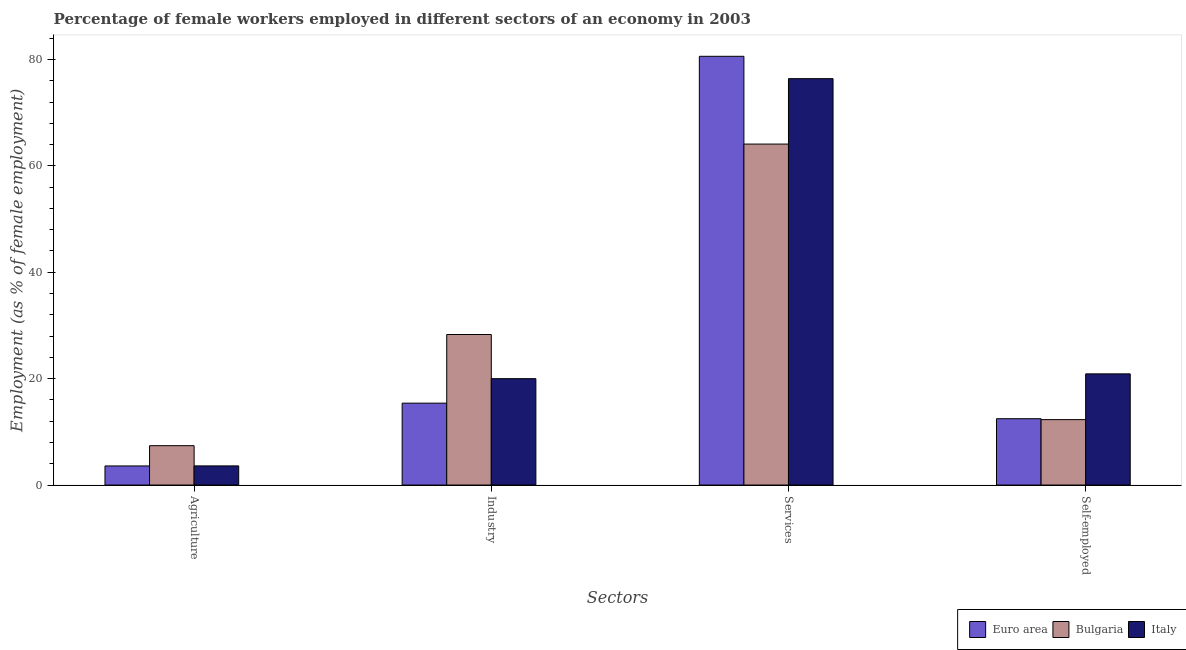How many different coloured bars are there?
Give a very brief answer. 3. How many groups of bars are there?
Your answer should be compact. 4. Are the number of bars per tick equal to the number of legend labels?
Provide a succinct answer. Yes. Are the number of bars on each tick of the X-axis equal?
Offer a terse response. Yes. How many bars are there on the 4th tick from the right?
Ensure brevity in your answer.  3. What is the label of the 2nd group of bars from the left?
Give a very brief answer. Industry. What is the percentage of female workers in services in Italy?
Your response must be concise. 76.4. Across all countries, what is the maximum percentage of self employed female workers?
Ensure brevity in your answer.  20.9. Across all countries, what is the minimum percentage of female workers in services?
Make the answer very short. 64.1. In which country was the percentage of female workers in agriculture maximum?
Provide a succinct answer. Bulgaria. What is the total percentage of female workers in services in the graph?
Keep it short and to the point. 221.1. What is the difference between the percentage of female workers in agriculture in Bulgaria and that in Euro area?
Ensure brevity in your answer.  3.81. What is the difference between the percentage of female workers in services in Italy and the percentage of female workers in industry in Bulgaria?
Make the answer very short. 48.1. What is the average percentage of self employed female workers per country?
Offer a very short reply. 15.22. What is the difference between the percentage of female workers in industry and percentage of female workers in services in Italy?
Keep it short and to the point. -56.4. In how many countries, is the percentage of female workers in services greater than 16 %?
Ensure brevity in your answer.  3. What is the ratio of the percentage of self employed female workers in Bulgaria to that in Euro area?
Give a very brief answer. 0.99. Is the percentage of female workers in services in Euro area less than that in Italy?
Offer a very short reply. No. Is the difference between the percentage of female workers in agriculture in Italy and Bulgaria greater than the difference between the percentage of female workers in industry in Italy and Bulgaria?
Your answer should be compact. Yes. What is the difference between the highest and the second highest percentage of female workers in industry?
Your response must be concise. 8.3. What is the difference between the highest and the lowest percentage of female workers in agriculture?
Keep it short and to the point. 3.81. Is the sum of the percentage of female workers in agriculture in Bulgaria and Italy greater than the maximum percentage of female workers in industry across all countries?
Keep it short and to the point. No. Is it the case that in every country, the sum of the percentage of female workers in services and percentage of female workers in industry is greater than the sum of percentage of self employed female workers and percentage of female workers in agriculture?
Make the answer very short. Yes. What does the 2nd bar from the right in Agriculture represents?
Give a very brief answer. Bulgaria. Is it the case that in every country, the sum of the percentage of female workers in agriculture and percentage of female workers in industry is greater than the percentage of female workers in services?
Provide a short and direct response. No. Are all the bars in the graph horizontal?
Offer a terse response. No. Are the values on the major ticks of Y-axis written in scientific E-notation?
Make the answer very short. No. Does the graph contain any zero values?
Provide a short and direct response. No. Does the graph contain grids?
Your answer should be compact. No. How are the legend labels stacked?
Your response must be concise. Horizontal. What is the title of the graph?
Offer a terse response. Percentage of female workers employed in different sectors of an economy in 2003. Does "Bolivia" appear as one of the legend labels in the graph?
Make the answer very short. No. What is the label or title of the X-axis?
Your answer should be very brief. Sectors. What is the label or title of the Y-axis?
Your answer should be very brief. Employment (as % of female employment). What is the Employment (as % of female employment) in Euro area in Agriculture?
Your answer should be compact. 3.59. What is the Employment (as % of female employment) of Bulgaria in Agriculture?
Keep it short and to the point. 7.4. What is the Employment (as % of female employment) of Italy in Agriculture?
Offer a very short reply. 3.6. What is the Employment (as % of female employment) of Euro area in Industry?
Your response must be concise. 15.4. What is the Employment (as % of female employment) in Bulgaria in Industry?
Make the answer very short. 28.3. What is the Employment (as % of female employment) in Italy in Industry?
Provide a short and direct response. 20. What is the Employment (as % of female employment) of Euro area in Services?
Provide a short and direct response. 80.6. What is the Employment (as % of female employment) in Bulgaria in Services?
Provide a succinct answer. 64.1. What is the Employment (as % of female employment) of Italy in Services?
Offer a terse response. 76.4. What is the Employment (as % of female employment) in Euro area in Self-employed?
Provide a short and direct response. 12.47. What is the Employment (as % of female employment) in Bulgaria in Self-employed?
Your response must be concise. 12.3. What is the Employment (as % of female employment) of Italy in Self-employed?
Offer a terse response. 20.9. Across all Sectors, what is the maximum Employment (as % of female employment) of Euro area?
Your answer should be compact. 80.6. Across all Sectors, what is the maximum Employment (as % of female employment) of Bulgaria?
Offer a terse response. 64.1. Across all Sectors, what is the maximum Employment (as % of female employment) of Italy?
Make the answer very short. 76.4. Across all Sectors, what is the minimum Employment (as % of female employment) of Euro area?
Provide a short and direct response. 3.59. Across all Sectors, what is the minimum Employment (as % of female employment) of Bulgaria?
Ensure brevity in your answer.  7.4. Across all Sectors, what is the minimum Employment (as % of female employment) of Italy?
Provide a succinct answer. 3.6. What is the total Employment (as % of female employment) in Euro area in the graph?
Provide a succinct answer. 112.06. What is the total Employment (as % of female employment) in Bulgaria in the graph?
Give a very brief answer. 112.1. What is the total Employment (as % of female employment) of Italy in the graph?
Provide a succinct answer. 120.9. What is the difference between the Employment (as % of female employment) in Euro area in Agriculture and that in Industry?
Offer a very short reply. -11.81. What is the difference between the Employment (as % of female employment) in Bulgaria in Agriculture and that in Industry?
Offer a terse response. -20.9. What is the difference between the Employment (as % of female employment) in Italy in Agriculture and that in Industry?
Provide a succinct answer. -16.4. What is the difference between the Employment (as % of female employment) in Euro area in Agriculture and that in Services?
Offer a terse response. -77.01. What is the difference between the Employment (as % of female employment) in Bulgaria in Agriculture and that in Services?
Your answer should be very brief. -56.7. What is the difference between the Employment (as % of female employment) of Italy in Agriculture and that in Services?
Ensure brevity in your answer.  -72.8. What is the difference between the Employment (as % of female employment) in Euro area in Agriculture and that in Self-employed?
Keep it short and to the point. -8.88. What is the difference between the Employment (as % of female employment) of Italy in Agriculture and that in Self-employed?
Offer a terse response. -17.3. What is the difference between the Employment (as % of female employment) of Euro area in Industry and that in Services?
Provide a succinct answer. -65.2. What is the difference between the Employment (as % of female employment) of Bulgaria in Industry and that in Services?
Ensure brevity in your answer.  -35.8. What is the difference between the Employment (as % of female employment) of Italy in Industry and that in Services?
Your answer should be very brief. -56.4. What is the difference between the Employment (as % of female employment) of Euro area in Industry and that in Self-employed?
Your answer should be compact. 2.93. What is the difference between the Employment (as % of female employment) in Italy in Industry and that in Self-employed?
Offer a very short reply. -0.9. What is the difference between the Employment (as % of female employment) of Euro area in Services and that in Self-employed?
Offer a very short reply. 68.13. What is the difference between the Employment (as % of female employment) of Bulgaria in Services and that in Self-employed?
Give a very brief answer. 51.8. What is the difference between the Employment (as % of female employment) in Italy in Services and that in Self-employed?
Provide a short and direct response. 55.5. What is the difference between the Employment (as % of female employment) of Euro area in Agriculture and the Employment (as % of female employment) of Bulgaria in Industry?
Offer a terse response. -24.71. What is the difference between the Employment (as % of female employment) of Euro area in Agriculture and the Employment (as % of female employment) of Italy in Industry?
Provide a succinct answer. -16.41. What is the difference between the Employment (as % of female employment) of Euro area in Agriculture and the Employment (as % of female employment) of Bulgaria in Services?
Ensure brevity in your answer.  -60.51. What is the difference between the Employment (as % of female employment) in Euro area in Agriculture and the Employment (as % of female employment) in Italy in Services?
Keep it short and to the point. -72.81. What is the difference between the Employment (as % of female employment) in Bulgaria in Agriculture and the Employment (as % of female employment) in Italy in Services?
Your response must be concise. -69. What is the difference between the Employment (as % of female employment) of Euro area in Agriculture and the Employment (as % of female employment) of Bulgaria in Self-employed?
Provide a succinct answer. -8.71. What is the difference between the Employment (as % of female employment) in Euro area in Agriculture and the Employment (as % of female employment) in Italy in Self-employed?
Your answer should be very brief. -17.31. What is the difference between the Employment (as % of female employment) of Euro area in Industry and the Employment (as % of female employment) of Bulgaria in Services?
Offer a very short reply. -48.7. What is the difference between the Employment (as % of female employment) of Euro area in Industry and the Employment (as % of female employment) of Italy in Services?
Provide a short and direct response. -61. What is the difference between the Employment (as % of female employment) in Bulgaria in Industry and the Employment (as % of female employment) in Italy in Services?
Ensure brevity in your answer.  -48.1. What is the difference between the Employment (as % of female employment) of Euro area in Industry and the Employment (as % of female employment) of Bulgaria in Self-employed?
Your answer should be very brief. 3.1. What is the difference between the Employment (as % of female employment) in Euro area in Industry and the Employment (as % of female employment) in Italy in Self-employed?
Give a very brief answer. -5.5. What is the difference between the Employment (as % of female employment) of Bulgaria in Industry and the Employment (as % of female employment) of Italy in Self-employed?
Your answer should be compact. 7.4. What is the difference between the Employment (as % of female employment) in Euro area in Services and the Employment (as % of female employment) in Bulgaria in Self-employed?
Keep it short and to the point. 68.3. What is the difference between the Employment (as % of female employment) of Euro area in Services and the Employment (as % of female employment) of Italy in Self-employed?
Provide a succinct answer. 59.7. What is the difference between the Employment (as % of female employment) of Bulgaria in Services and the Employment (as % of female employment) of Italy in Self-employed?
Your response must be concise. 43.2. What is the average Employment (as % of female employment) of Euro area per Sectors?
Keep it short and to the point. 28.01. What is the average Employment (as % of female employment) in Bulgaria per Sectors?
Provide a succinct answer. 28.02. What is the average Employment (as % of female employment) in Italy per Sectors?
Offer a terse response. 30.23. What is the difference between the Employment (as % of female employment) of Euro area and Employment (as % of female employment) of Bulgaria in Agriculture?
Keep it short and to the point. -3.81. What is the difference between the Employment (as % of female employment) of Euro area and Employment (as % of female employment) of Italy in Agriculture?
Keep it short and to the point. -0.01. What is the difference between the Employment (as % of female employment) of Euro area and Employment (as % of female employment) of Bulgaria in Industry?
Provide a succinct answer. -12.9. What is the difference between the Employment (as % of female employment) in Euro area and Employment (as % of female employment) in Italy in Industry?
Provide a short and direct response. -4.6. What is the difference between the Employment (as % of female employment) of Bulgaria and Employment (as % of female employment) of Italy in Industry?
Keep it short and to the point. 8.3. What is the difference between the Employment (as % of female employment) of Euro area and Employment (as % of female employment) of Bulgaria in Services?
Offer a terse response. 16.5. What is the difference between the Employment (as % of female employment) of Euro area and Employment (as % of female employment) of Italy in Services?
Keep it short and to the point. 4.2. What is the difference between the Employment (as % of female employment) in Bulgaria and Employment (as % of female employment) in Italy in Services?
Your response must be concise. -12.3. What is the difference between the Employment (as % of female employment) of Euro area and Employment (as % of female employment) of Bulgaria in Self-employed?
Ensure brevity in your answer.  0.17. What is the difference between the Employment (as % of female employment) in Euro area and Employment (as % of female employment) in Italy in Self-employed?
Ensure brevity in your answer.  -8.43. What is the difference between the Employment (as % of female employment) of Bulgaria and Employment (as % of female employment) of Italy in Self-employed?
Provide a succinct answer. -8.6. What is the ratio of the Employment (as % of female employment) of Euro area in Agriculture to that in Industry?
Give a very brief answer. 0.23. What is the ratio of the Employment (as % of female employment) of Bulgaria in Agriculture to that in Industry?
Keep it short and to the point. 0.26. What is the ratio of the Employment (as % of female employment) of Italy in Agriculture to that in Industry?
Offer a terse response. 0.18. What is the ratio of the Employment (as % of female employment) of Euro area in Agriculture to that in Services?
Give a very brief answer. 0.04. What is the ratio of the Employment (as % of female employment) of Bulgaria in Agriculture to that in Services?
Give a very brief answer. 0.12. What is the ratio of the Employment (as % of female employment) of Italy in Agriculture to that in Services?
Keep it short and to the point. 0.05. What is the ratio of the Employment (as % of female employment) of Euro area in Agriculture to that in Self-employed?
Your response must be concise. 0.29. What is the ratio of the Employment (as % of female employment) in Bulgaria in Agriculture to that in Self-employed?
Ensure brevity in your answer.  0.6. What is the ratio of the Employment (as % of female employment) in Italy in Agriculture to that in Self-employed?
Offer a terse response. 0.17. What is the ratio of the Employment (as % of female employment) of Euro area in Industry to that in Services?
Keep it short and to the point. 0.19. What is the ratio of the Employment (as % of female employment) in Bulgaria in Industry to that in Services?
Give a very brief answer. 0.44. What is the ratio of the Employment (as % of female employment) of Italy in Industry to that in Services?
Offer a very short reply. 0.26. What is the ratio of the Employment (as % of female employment) in Euro area in Industry to that in Self-employed?
Provide a succinct answer. 1.23. What is the ratio of the Employment (as % of female employment) of Bulgaria in Industry to that in Self-employed?
Provide a short and direct response. 2.3. What is the ratio of the Employment (as % of female employment) of Italy in Industry to that in Self-employed?
Offer a terse response. 0.96. What is the ratio of the Employment (as % of female employment) of Euro area in Services to that in Self-employed?
Give a very brief answer. 6.46. What is the ratio of the Employment (as % of female employment) in Bulgaria in Services to that in Self-employed?
Your response must be concise. 5.21. What is the ratio of the Employment (as % of female employment) in Italy in Services to that in Self-employed?
Provide a succinct answer. 3.66. What is the difference between the highest and the second highest Employment (as % of female employment) of Euro area?
Provide a succinct answer. 65.2. What is the difference between the highest and the second highest Employment (as % of female employment) in Bulgaria?
Provide a succinct answer. 35.8. What is the difference between the highest and the second highest Employment (as % of female employment) in Italy?
Offer a terse response. 55.5. What is the difference between the highest and the lowest Employment (as % of female employment) in Euro area?
Give a very brief answer. 77.01. What is the difference between the highest and the lowest Employment (as % of female employment) of Bulgaria?
Provide a short and direct response. 56.7. What is the difference between the highest and the lowest Employment (as % of female employment) in Italy?
Your answer should be compact. 72.8. 